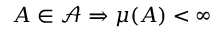Convert formula to latex. <formula><loc_0><loc_0><loc_500><loc_500>A \in { \mathcal { A } } \Rightarrow \mu ( A ) < \infty</formula> 